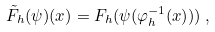Convert formula to latex. <formula><loc_0><loc_0><loc_500><loc_500>\tilde { F } _ { h } ( \psi ) ( x ) = F _ { h } ( \psi ( \varphi _ { h } ^ { - 1 } ( x ) ) ) \, ,</formula> 